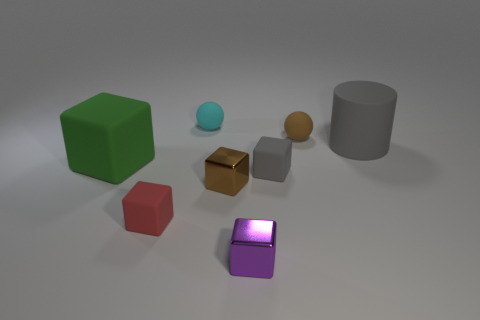Describe the lighting and mood conveyed by the setting in this image. The image displays a soft, diffused lighting that casts gentle shadows beneath the objects, suggesting a calm and neutral mood. There's no strong directional light source, but there appears to be an ambient light illuminating the scene evenly, creating a tranquil and nondescript atmosphere. 